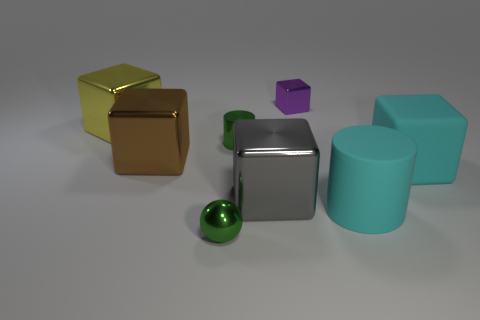Subtract 3 blocks. How many blocks are left? 2 Subtract all gray cubes. How many cubes are left? 4 Subtract all brown shiny cubes. How many cubes are left? 4 Subtract all purple cubes. Subtract all blue balls. How many cubes are left? 4 Add 1 small green things. How many objects exist? 9 Subtract all cylinders. How many objects are left? 6 Subtract all big brown cubes. Subtract all purple metal cubes. How many objects are left? 6 Add 5 tiny green things. How many tiny green things are left? 7 Add 7 metal cylinders. How many metal cylinders exist? 8 Subtract 0 yellow balls. How many objects are left? 8 